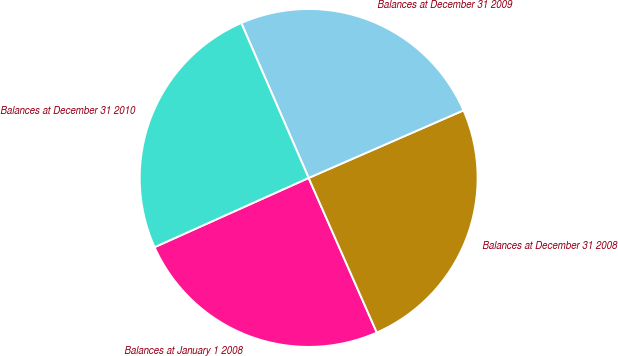Convert chart. <chart><loc_0><loc_0><loc_500><loc_500><pie_chart><fcel>Balances at January 1 2008<fcel>Balances at December 31 2008<fcel>Balances at December 31 2009<fcel>Balances at December 31 2010<nl><fcel>24.89%<fcel>24.94%<fcel>24.98%<fcel>25.19%<nl></chart> 